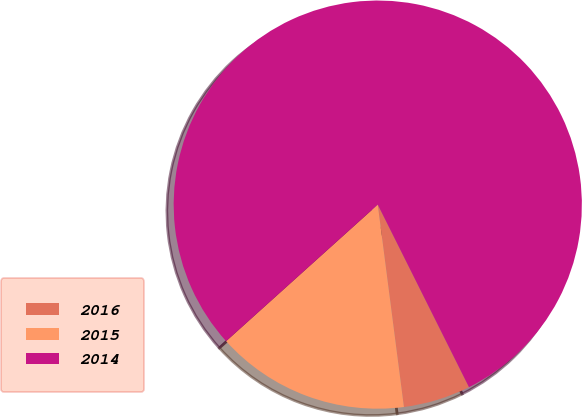<chart> <loc_0><loc_0><loc_500><loc_500><pie_chart><fcel>2016<fcel>2015<fcel>2014<nl><fcel>5.33%<fcel>15.38%<fcel>79.29%<nl></chart> 